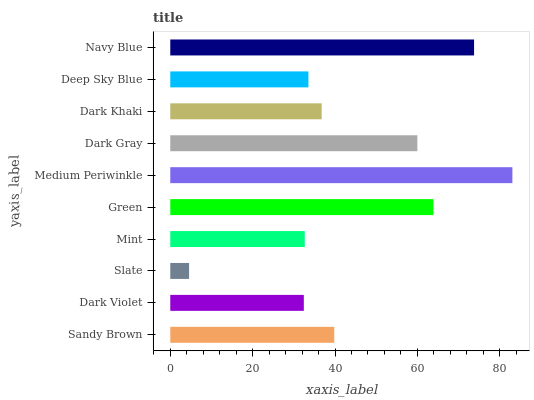Is Slate the minimum?
Answer yes or no. Yes. Is Medium Periwinkle the maximum?
Answer yes or no. Yes. Is Dark Violet the minimum?
Answer yes or no. No. Is Dark Violet the maximum?
Answer yes or no. No. Is Sandy Brown greater than Dark Violet?
Answer yes or no. Yes. Is Dark Violet less than Sandy Brown?
Answer yes or no. Yes. Is Dark Violet greater than Sandy Brown?
Answer yes or no. No. Is Sandy Brown less than Dark Violet?
Answer yes or no. No. Is Sandy Brown the high median?
Answer yes or no. Yes. Is Dark Khaki the low median?
Answer yes or no. Yes. Is Green the high median?
Answer yes or no. No. Is Slate the low median?
Answer yes or no. No. 